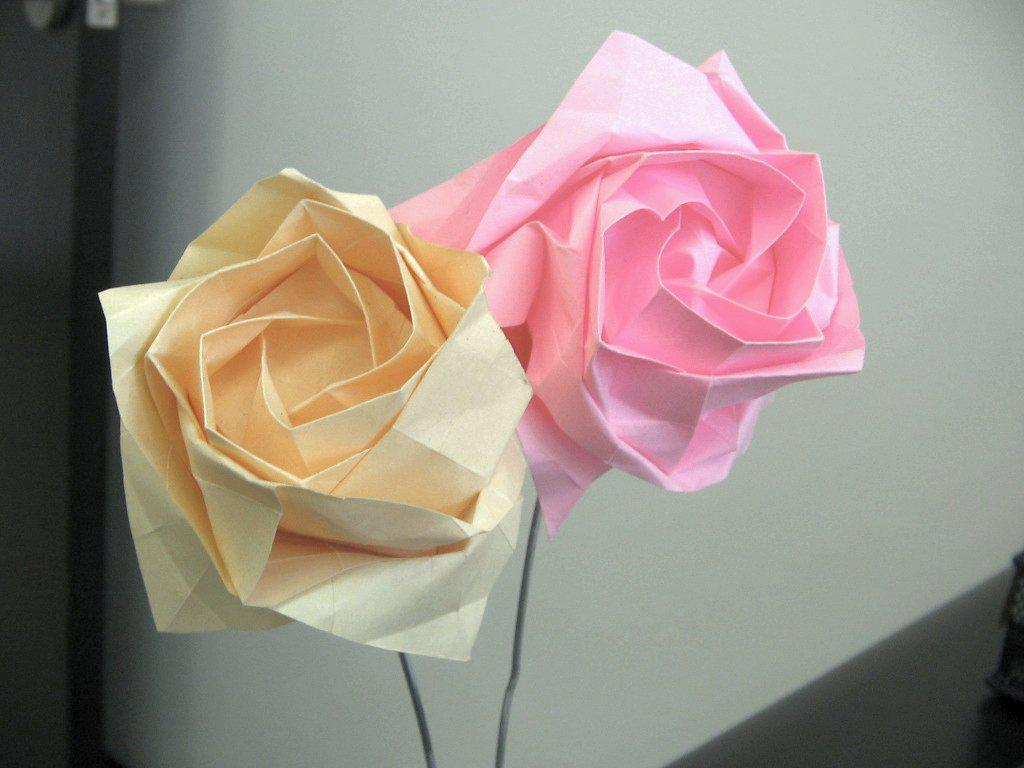What type of flowers are depicted in the image? There are flowers made up of paper in the image. Where are the paper flowers located in the image? The flowers are in the front of the image. What can be seen in the background of the image? There is a white wall in the background of the image. What type of feast is being prepared in the image? There is no feast or any indication of food preparation in the image; it features paper flowers in the front and a white wall in the background. 